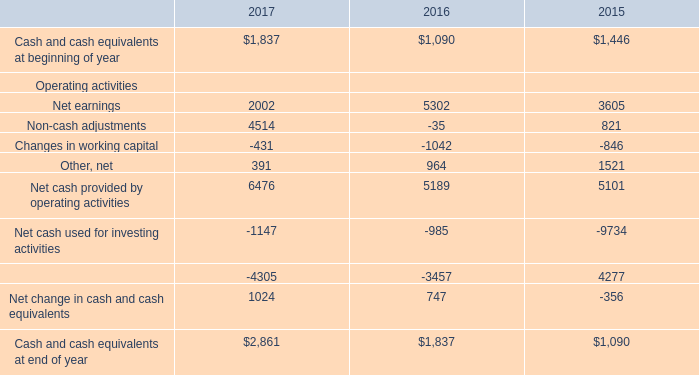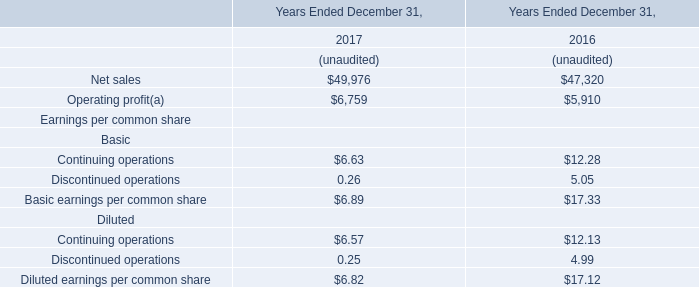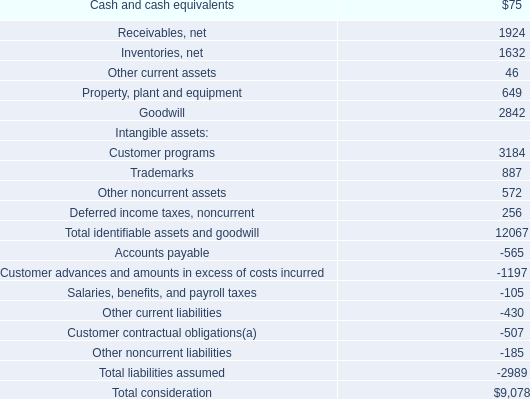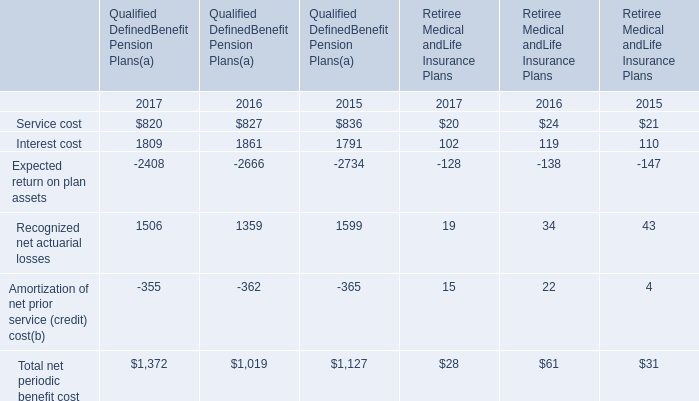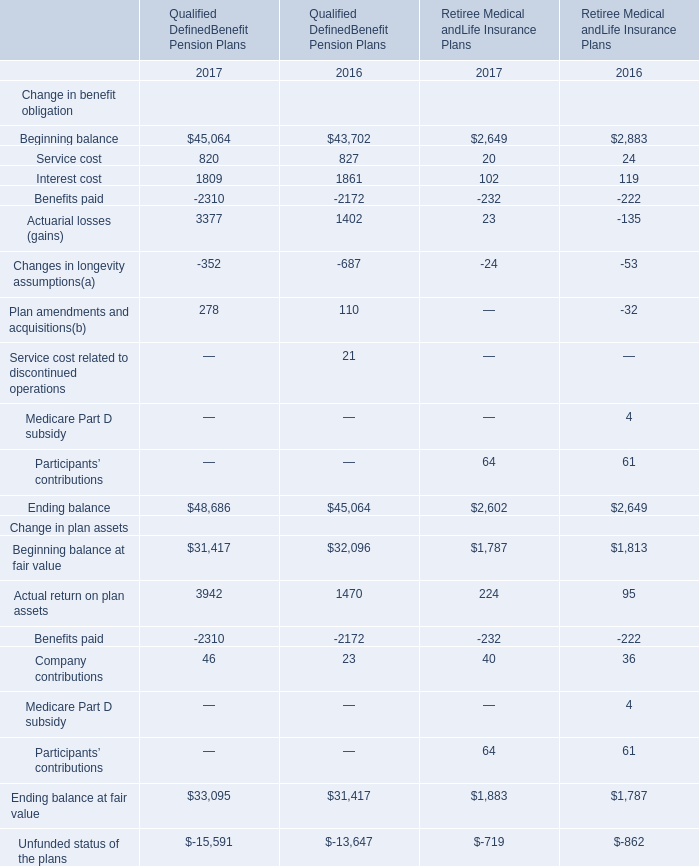What's the average of Beginning balance in Qualified DefinedBenefit Pension Plans (in million) 
Computations: ((45064 + 43702) / 2)
Answer: 44383.0. 